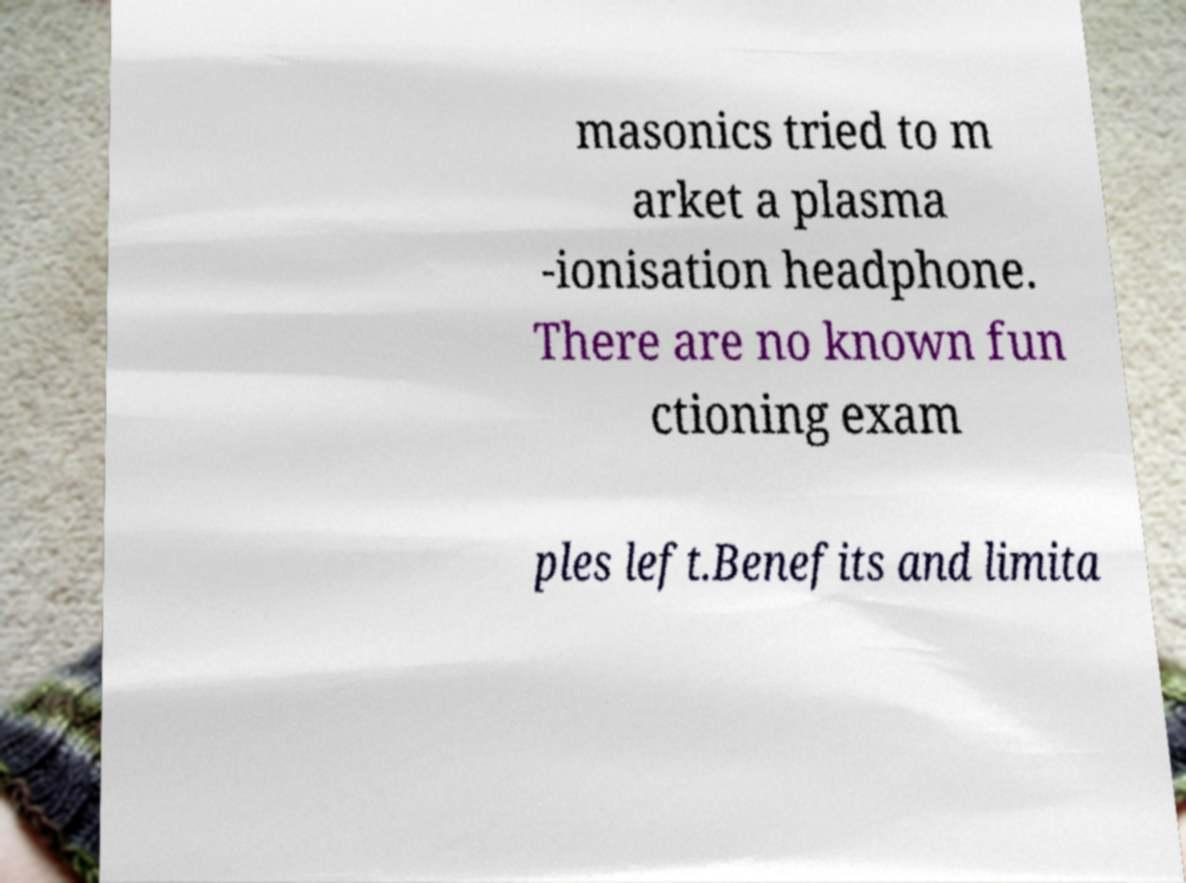Could you extract and type out the text from this image? masonics tried to m arket a plasma -ionisation headphone. There are no known fun ctioning exam ples left.Benefits and limita 